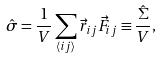Convert formula to latex. <formula><loc_0><loc_0><loc_500><loc_500>\hat { \sigma } = \frac { 1 } { V } \sum _ { \langle i j \rangle } \vec { r } _ { i j } \vec { F } _ { i j } \equiv \frac { \hat { \Sigma } } { V } ,</formula> 